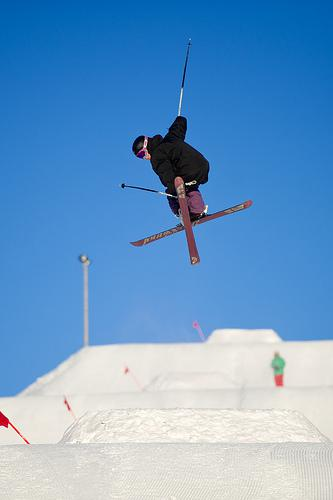Question: what sport is shown?
Choices:
A. Sledding.
B. Skiing.
C. Curling.
D. Hockey.
Answer with the letter. Answer: B Question: who is pictured?
Choices:
A. Skier.
B. Sledder.
C. Swimmer.
D. Wrestler.
Answer with the letter. Answer: A Question: what color are the side flags?
Choices:
A. Blue.
B. Yellow.
C. Green.
D. Red.
Answer with the letter. Answer: D Question: how many people are there?
Choices:
A. 2.
B. 3.
C. 4.
D. 5.
Answer with the letter. Answer: A Question: how many flags do you see?
Choices:
A. 4.
B. 5.
C. 6.
D. 7.
Answer with the letter. Answer: A Question: what color is are the skis?
Choices:
A. Red.
B. Purple.
C. Pink.
D. Green.
Answer with the letter. Answer: B 